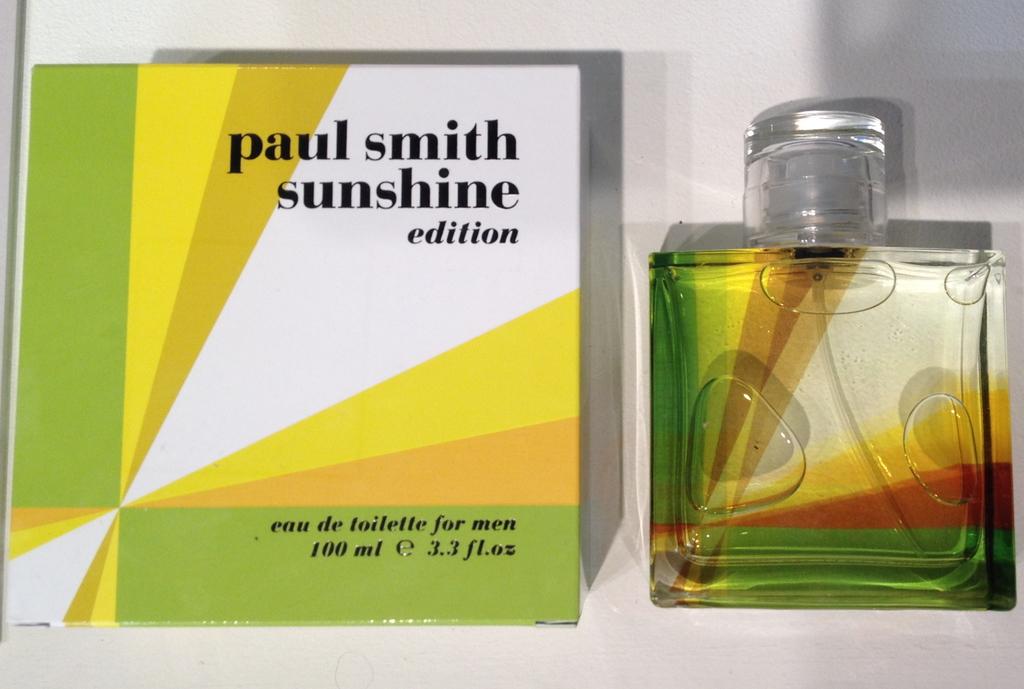What is the brand of perfume?
Keep it short and to the point. Paul smith sunshine. 